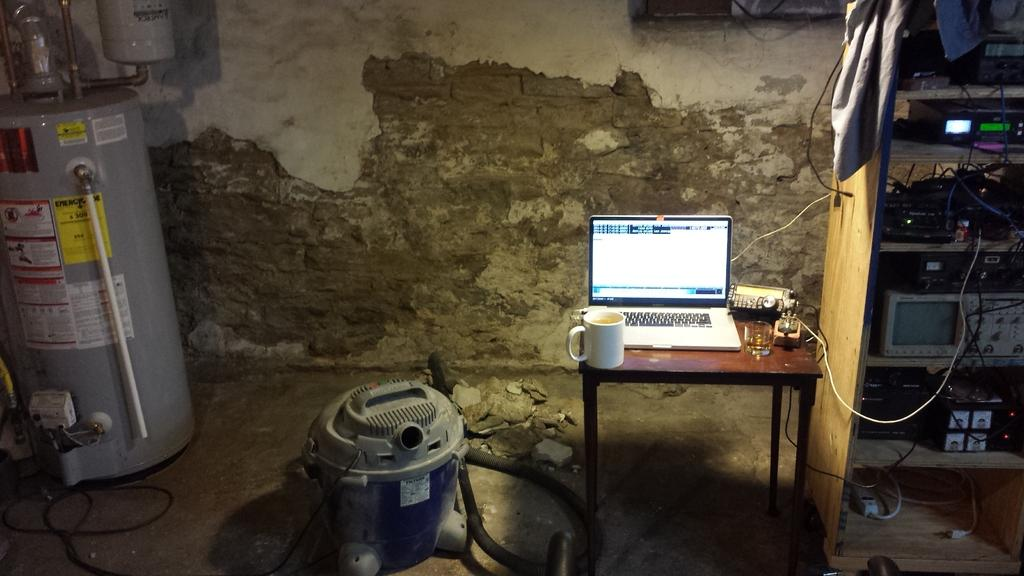What electronic device is visible in the image? There is a laptop in the image. What type of beverage container can be seen in the image? There is a cup and a glass in the image. What is the setting where the laptop and beverage containers are located? The laptop, cup, and glass are on a table in the image. What else can be seen on the table in the image? There are many equipment on the table in the image. What is the background of the image? There is a wall in the background of the image. What type of pancake is being served at the queen's feast in the image? There is no queen, feast, or pancake present in the image. 